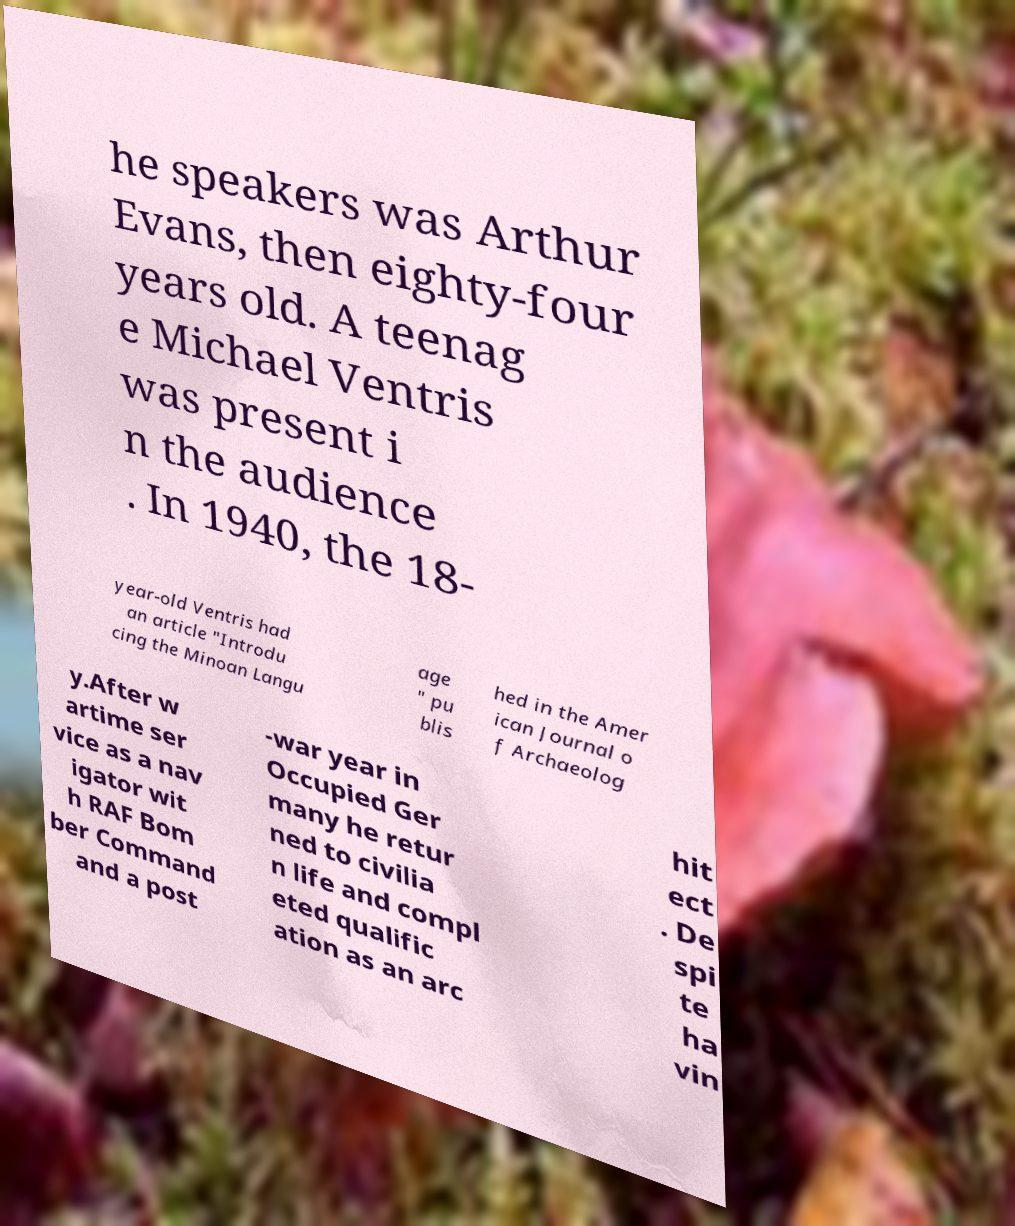I need the written content from this picture converted into text. Can you do that? he speakers was Arthur Evans, then eighty-four years old. A teenag e Michael Ventris was present i n the audience . In 1940, the 18- year-old Ventris had an article "Introdu cing the Minoan Langu age " pu blis hed in the Amer ican Journal o f Archaeolog y.After w artime ser vice as a nav igator wit h RAF Bom ber Command and a post -war year in Occupied Ger many he retur ned to civilia n life and compl eted qualific ation as an arc hit ect . De spi te ha vin 